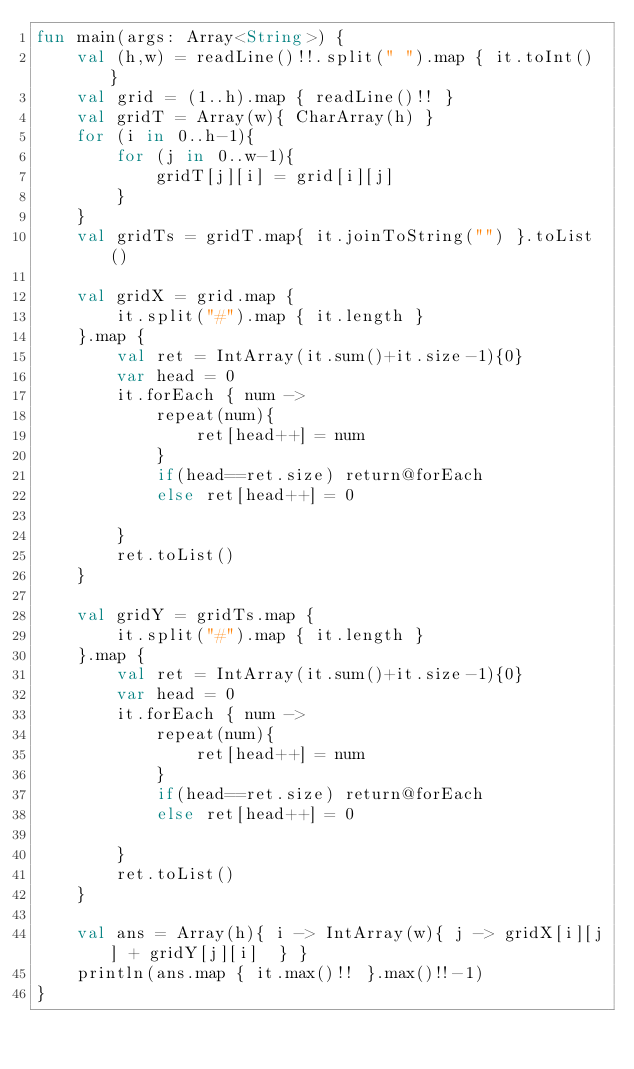<code> <loc_0><loc_0><loc_500><loc_500><_Kotlin_>fun main(args: Array<String>) {
    val (h,w) = readLine()!!.split(" ").map { it.toInt() }
    val grid = (1..h).map { readLine()!! }
    val gridT = Array(w){ CharArray(h) }
    for (i in 0..h-1){
        for (j in 0..w-1){
            gridT[j][i] = grid[i][j]
        }
    }
    val gridTs = gridT.map{ it.joinToString("") }.toList()
    
    val gridX = grid.map {
        it.split("#").map { it.length }
    }.map {
        val ret = IntArray(it.sum()+it.size-1){0}
        var head = 0
        it.forEach { num ->
            repeat(num){
                ret[head++] = num
            }
            if(head==ret.size) return@forEach
            else ret[head++] = 0

        }
        ret.toList()
    }

    val gridY = gridTs.map {
        it.split("#").map { it.length }
    }.map {
        val ret = IntArray(it.sum()+it.size-1){0}
        var head = 0
        it.forEach { num ->
            repeat(num){
                ret[head++] = num
            }
            if(head==ret.size) return@forEach
            else ret[head++] = 0

        }
        ret.toList()
    }

    val ans = Array(h){ i -> IntArray(w){ j -> gridX[i][j] + gridY[j][i]  } }
    println(ans.map { it.max()!! }.max()!!-1)
}</code> 